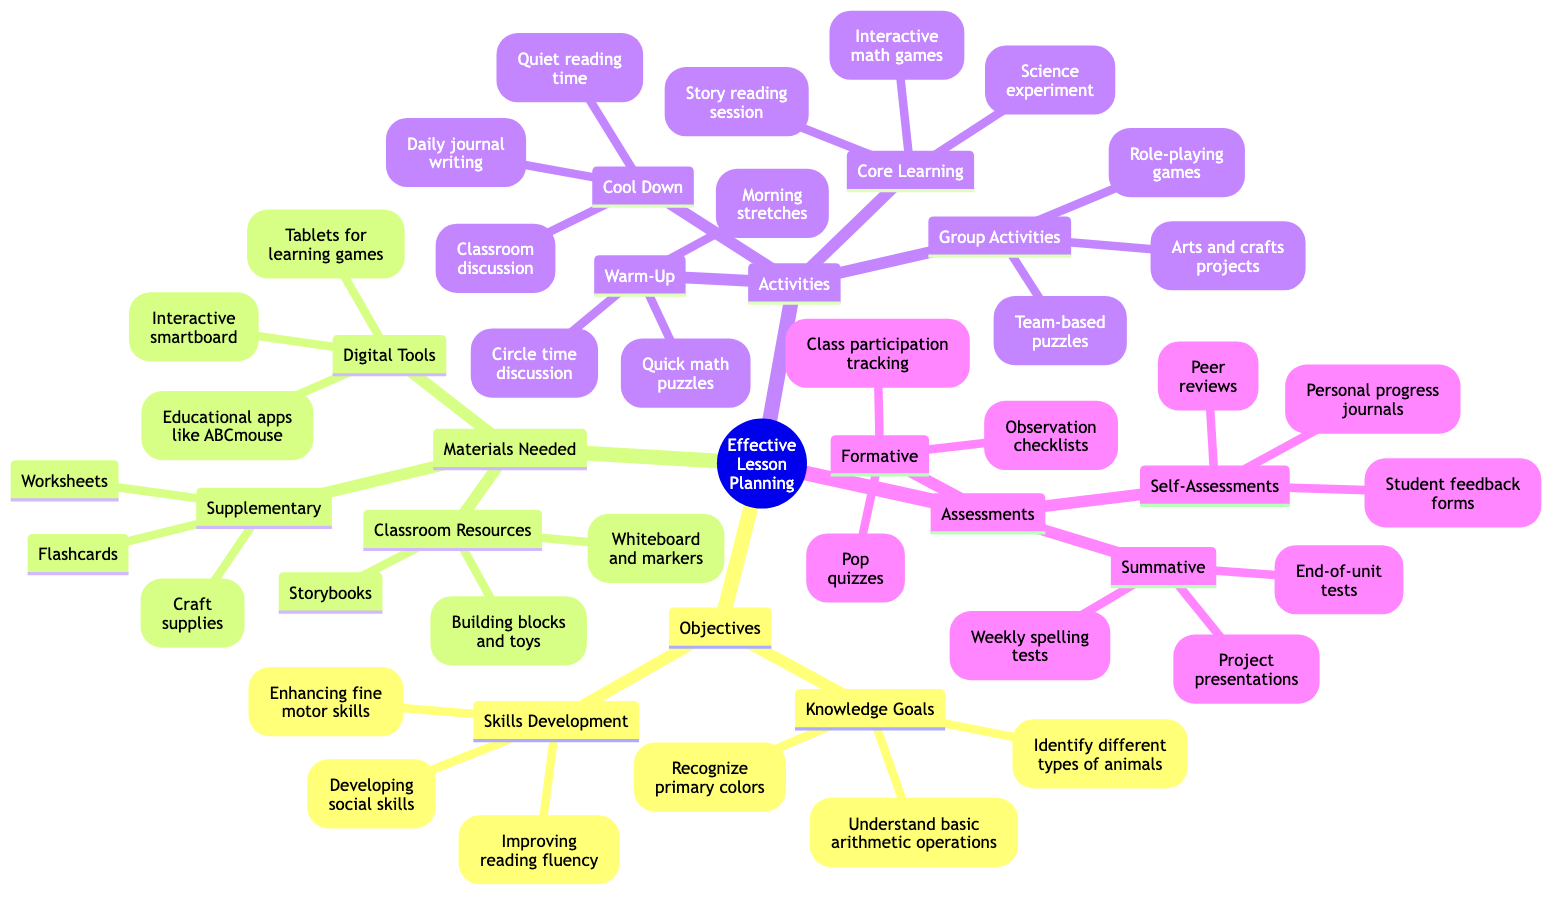What is one of the knowledge goals in the objectives? The diagram lists several knowledge goals under the objectives category. By viewing this section, one can identify that "Understand basic arithmetic operations" is mentioned as one of the goals.
Answer: Understand basic arithmetic operations How many main categories are there under "Effective Lesson Planning"? The diagram has four main categories branching from "Effective Lesson Planning" - Objectives, Materials Needed, Activities, and Assessments. By counting these main branches, we can confirm that there are four.
Answer: 4 What type of assessment includes "Pop quizzes"? The diagram categorizes assessments into formative, summative, and self-assessments. "Pop quizzes" are found under the formative assessments section, which is specifically designed to evaluate students’ understanding during the learning process.
Answer: Formative Name one classroom resource listed in the materials needed. Under the materials needed section, classroom resources are specified. Looking closely, we can see that "Whiteboard and markers" is one example mentioned in this category.
Answer: Whiteboard and markers What activity is categorized as a warm-up exercise? Examining the activities section in the mind map reveals that "Circle time discussion" is listed as one of the warm-up exercises, indicating its role in preparing students for the day’s learning.
Answer: Circle time discussion Which group activity involves problem-solving? The activities section highlights various group activities. Among them, "Team-based puzzles" stands out as an activity focused on collaborative problem-solving among students, emphasizing teamwork and critical thinking.
Answer: Team-based puzzles How many types of materials are listed under "Digital Tools"? In the materials needed section, there are three distinct entries listed under digital tools: "Interactive smartboard," "Educational apps like ABCmouse," and "Tablets for interactive learning games." By counting these, we see there are three types.
Answer: 3 Identify one self-assessment method listed. The self-assessments section in the diagram includes various methods. One of them is "Student feedback forms," which allows students to reflect on their learning experiences and provide input on their progress.
Answer: Student feedback forms What is a core learning activity provided in the diagram? Looking at the core learning activities specified in the activities section, it's clear that "Science experiment demonstration" is a core part of the learning process aimed at engaging students in hands-on learning experiences.
Answer: Science experiment demonstration 